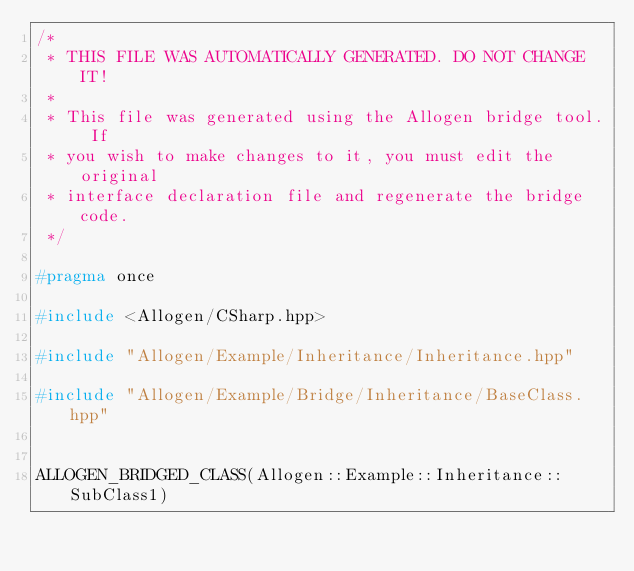Convert code to text. <code><loc_0><loc_0><loc_500><loc_500><_C++_>/*
 * THIS FILE WAS AUTOMATICALLY GENERATED. DO NOT CHANGE IT!
 *
 * This file was generated using the Allogen bridge tool. If
 * you wish to make changes to it, you must edit the original
 * interface declaration file and regenerate the bridge code.
 */

#pragma once

#include <Allogen/CSharp.hpp>

#include "Allogen/Example/Inheritance/Inheritance.hpp"

#include "Allogen/Example/Bridge/Inheritance/BaseClass.hpp"


ALLOGEN_BRIDGED_CLASS(Allogen::Example::Inheritance::SubClass1)
</code> 